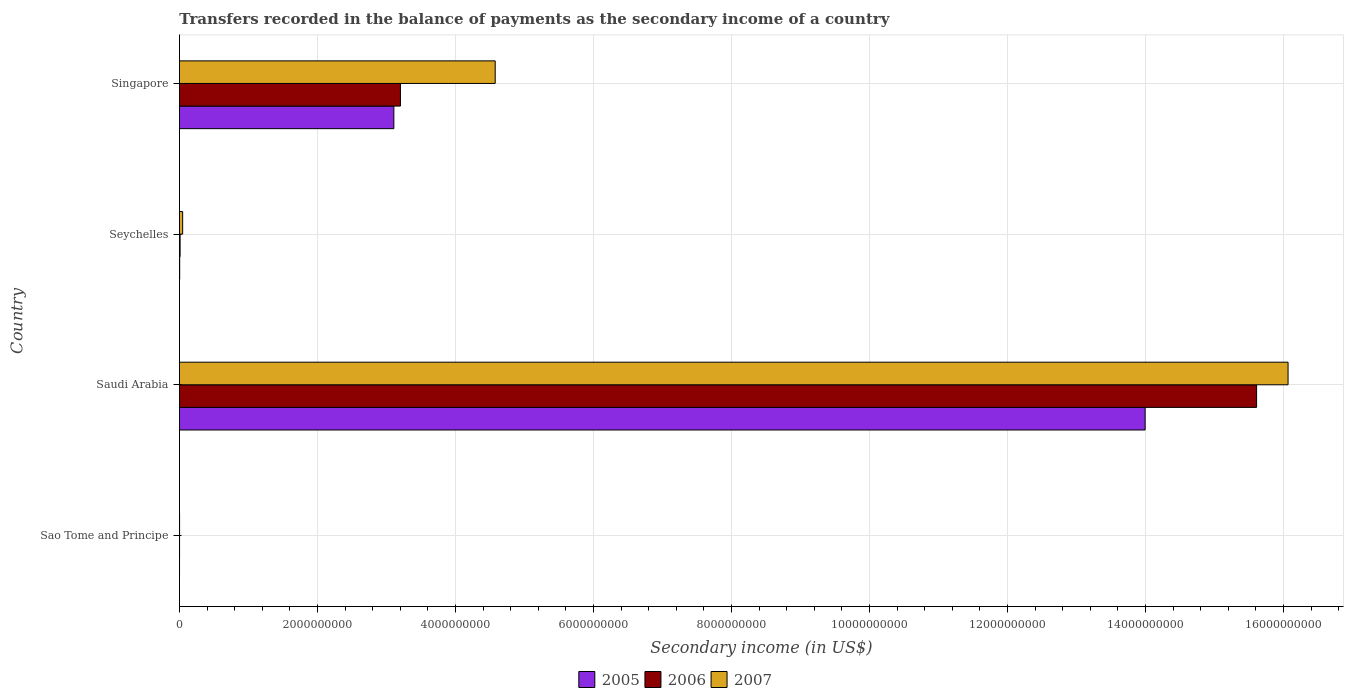Are the number of bars per tick equal to the number of legend labels?
Make the answer very short. Yes. Are the number of bars on each tick of the Y-axis equal?
Ensure brevity in your answer.  Yes. What is the label of the 2nd group of bars from the top?
Make the answer very short. Seychelles. In how many cases, is the number of bars for a given country not equal to the number of legend labels?
Provide a succinct answer. 0. What is the secondary income of in 2005 in Seychelles?
Make the answer very short. 3.99e+06. Across all countries, what is the maximum secondary income of in 2007?
Provide a succinct answer. 1.61e+1. Across all countries, what is the minimum secondary income of in 2005?
Offer a terse response. 1.46e+06. In which country was the secondary income of in 2005 maximum?
Offer a terse response. Saudi Arabia. In which country was the secondary income of in 2005 minimum?
Your response must be concise. Sao Tome and Principe. What is the total secondary income of in 2007 in the graph?
Your response must be concise. 2.07e+1. What is the difference between the secondary income of in 2005 in Sao Tome and Principe and that in Seychelles?
Give a very brief answer. -2.54e+06. What is the difference between the secondary income of in 2006 in Singapore and the secondary income of in 2007 in Sao Tome and Principe?
Offer a terse response. 3.20e+09. What is the average secondary income of in 2006 per country?
Ensure brevity in your answer.  4.71e+09. What is the difference between the secondary income of in 2007 and secondary income of in 2006 in Singapore?
Ensure brevity in your answer.  1.37e+09. In how many countries, is the secondary income of in 2006 greater than 8000000000 US$?
Make the answer very short. 1. What is the ratio of the secondary income of in 2006 in Sao Tome and Principe to that in Seychelles?
Your answer should be very brief. 0.23. Is the secondary income of in 2006 in Sao Tome and Principe less than that in Seychelles?
Offer a very short reply. Yes. What is the difference between the highest and the second highest secondary income of in 2005?
Your answer should be very brief. 1.09e+1. What is the difference between the highest and the lowest secondary income of in 2006?
Your answer should be compact. 1.56e+1. What does the 1st bar from the bottom in Singapore represents?
Your answer should be compact. 2005. Is it the case that in every country, the sum of the secondary income of in 2006 and secondary income of in 2005 is greater than the secondary income of in 2007?
Your answer should be compact. No. How many bars are there?
Make the answer very short. 12. Does the graph contain any zero values?
Offer a terse response. No. Where does the legend appear in the graph?
Ensure brevity in your answer.  Bottom center. How are the legend labels stacked?
Give a very brief answer. Horizontal. What is the title of the graph?
Provide a short and direct response. Transfers recorded in the balance of payments as the secondary income of a country. Does "1978" appear as one of the legend labels in the graph?
Offer a terse response. No. What is the label or title of the X-axis?
Give a very brief answer. Secondary income (in US$). What is the Secondary income (in US$) of 2005 in Sao Tome and Principe?
Your response must be concise. 1.46e+06. What is the Secondary income (in US$) in 2006 in Sao Tome and Principe?
Ensure brevity in your answer.  2.23e+06. What is the Secondary income (in US$) in 2007 in Sao Tome and Principe?
Your response must be concise. 2.27e+06. What is the Secondary income (in US$) in 2005 in Saudi Arabia?
Your answer should be very brief. 1.40e+1. What is the Secondary income (in US$) of 2006 in Saudi Arabia?
Make the answer very short. 1.56e+1. What is the Secondary income (in US$) in 2007 in Saudi Arabia?
Provide a succinct answer. 1.61e+1. What is the Secondary income (in US$) of 2005 in Seychelles?
Provide a succinct answer. 3.99e+06. What is the Secondary income (in US$) in 2006 in Seychelles?
Offer a terse response. 9.75e+06. What is the Secondary income (in US$) of 2007 in Seychelles?
Your response must be concise. 4.69e+07. What is the Secondary income (in US$) of 2005 in Singapore?
Ensure brevity in your answer.  3.11e+09. What is the Secondary income (in US$) in 2006 in Singapore?
Keep it short and to the point. 3.20e+09. What is the Secondary income (in US$) in 2007 in Singapore?
Give a very brief answer. 4.58e+09. Across all countries, what is the maximum Secondary income (in US$) of 2005?
Your answer should be compact. 1.40e+1. Across all countries, what is the maximum Secondary income (in US$) in 2006?
Your answer should be very brief. 1.56e+1. Across all countries, what is the maximum Secondary income (in US$) of 2007?
Provide a succinct answer. 1.61e+1. Across all countries, what is the minimum Secondary income (in US$) in 2005?
Offer a terse response. 1.46e+06. Across all countries, what is the minimum Secondary income (in US$) of 2006?
Your answer should be compact. 2.23e+06. Across all countries, what is the minimum Secondary income (in US$) of 2007?
Provide a short and direct response. 2.27e+06. What is the total Secondary income (in US$) in 2005 in the graph?
Ensure brevity in your answer.  1.71e+1. What is the total Secondary income (in US$) of 2006 in the graph?
Offer a very short reply. 1.88e+1. What is the total Secondary income (in US$) of 2007 in the graph?
Provide a succinct answer. 2.07e+1. What is the difference between the Secondary income (in US$) in 2005 in Sao Tome and Principe and that in Saudi Arabia?
Your answer should be compact. -1.40e+1. What is the difference between the Secondary income (in US$) in 2006 in Sao Tome and Principe and that in Saudi Arabia?
Make the answer very short. -1.56e+1. What is the difference between the Secondary income (in US$) of 2007 in Sao Tome and Principe and that in Saudi Arabia?
Keep it short and to the point. -1.61e+1. What is the difference between the Secondary income (in US$) of 2005 in Sao Tome and Principe and that in Seychelles?
Your response must be concise. -2.54e+06. What is the difference between the Secondary income (in US$) in 2006 in Sao Tome and Principe and that in Seychelles?
Give a very brief answer. -7.52e+06. What is the difference between the Secondary income (in US$) in 2007 in Sao Tome and Principe and that in Seychelles?
Give a very brief answer. -4.47e+07. What is the difference between the Secondary income (in US$) of 2005 in Sao Tome and Principe and that in Singapore?
Your answer should be compact. -3.11e+09. What is the difference between the Secondary income (in US$) of 2006 in Sao Tome and Principe and that in Singapore?
Ensure brevity in your answer.  -3.20e+09. What is the difference between the Secondary income (in US$) of 2007 in Sao Tome and Principe and that in Singapore?
Provide a short and direct response. -4.57e+09. What is the difference between the Secondary income (in US$) in 2005 in Saudi Arabia and that in Seychelles?
Offer a very short reply. 1.40e+1. What is the difference between the Secondary income (in US$) of 2006 in Saudi Arabia and that in Seychelles?
Keep it short and to the point. 1.56e+1. What is the difference between the Secondary income (in US$) in 2007 in Saudi Arabia and that in Seychelles?
Keep it short and to the point. 1.60e+1. What is the difference between the Secondary income (in US$) of 2005 in Saudi Arabia and that in Singapore?
Make the answer very short. 1.09e+1. What is the difference between the Secondary income (in US$) of 2006 in Saudi Arabia and that in Singapore?
Your answer should be very brief. 1.24e+1. What is the difference between the Secondary income (in US$) of 2007 in Saudi Arabia and that in Singapore?
Make the answer very short. 1.15e+1. What is the difference between the Secondary income (in US$) in 2005 in Seychelles and that in Singapore?
Give a very brief answer. -3.10e+09. What is the difference between the Secondary income (in US$) in 2006 in Seychelles and that in Singapore?
Your answer should be very brief. -3.19e+09. What is the difference between the Secondary income (in US$) in 2007 in Seychelles and that in Singapore?
Offer a terse response. -4.53e+09. What is the difference between the Secondary income (in US$) in 2005 in Sao Tome and Principe and the Secondary income (in US$) in 2006 in Saudi Arabia?
Make the answer very short. -1.56e+1. What is the difference between the Secondary income (in US$) of 2005 in Sao Tome and Principe and the Secondary income (in US$) of 2007 in Saudi Arabia?
Offer a very short reply. -1.61e+1. What is the difference between the Secondary income (in US$) in 2006 in Sao Tome and Principe and the Secondary income (in US$) in 2007 in Saudi Arabia?
Give a very brief answer. -1.61e+1. What is the difference between the Secondary income (in US$) in 2005 in Sao Tome and Principe and the Secondary income (in US$) in 2006 in Seychelles?
Give a very brief answer. -8.29e+06. What is the difference between the Secondary income (in US$) of 2005 in Sao Tome and Principe and the Secondary income (in US$) of 2007 in Seychelles?
Make the answer very short. -4.55e+07. What is the difference between the Secondary income (in US$) in 2006 in Sao Tome and Principe and the Secondary income (in US$) in 2007 in Seychelles?
Give a very brief answer. -4.47e+07. What is the difference between the Secondary income (in US$) of 2005 in Sao Tome and Principe and the Secondary income (in US$) of 2006 in Singapore?
Offer a terse response. -3.20e+09. What is the difference between the Secondary income (in US$) in 2005 in Sao Tome and Principe and the Secondary income (in US$) in 2007 in Singapore?
Your answer should be very brief. -4.58e+09. What is the difference between the Secondary income (in US$) in 2006 in Sao Tome and Principe and the Secondary income (in US$) in 2007 in Singapore?
Offer a terse response. -4.57e+09. What is the difference between the Secondary income (in US$) of 2005 in Saudi Arabia and the Secondary income (in US$) of 2006 in Seychelles?
Offer a terse response. 1.40e+1. What is the difference between the Secondary income (in US$) in 2005 in Saudi Arabia and the Secondary income (in US$) in 2007 in Seychelles?
Your response must be concise. 1.39e+1. What is the difference between the Secondary income (in US$) of 2006 in Saudi Arabia and the Secondary income (in US$) of 2007 in Seychelles?
Keep it short and to the point. 1.56e+1. What is the difference between the Secondary income (in US$) of 2005 in Saudi Arabia and the Secondary income (in US$) of 2006 in Singapore?
Your answer should be very brief. 1.08e+1. What is the difference between the Secondary income (in US$) in 2005 in Saudi Arabia and the Secondary income (in US$) in 2007 in Singapore?
Provide a succinct answer. 9.42e+09. What is the difference between the Secondary income (in US$) of 2006 in Saudi Arabia and the Secondary income (in US$) of 2007 in Singapore?
Offer a terse response. 1.10e+1. What is the difference between the Secondary income (in US$) of 2005 in Seychelles and the Secondary income (in US$) of 2006 in Singapore?
Provide a succinct answer. -3.20e+09. What is the difference between the Secondary income (in US$) of 2005 in Seychelles and the Secondary income (in US$) of 2007 in Singapore?
Give a very brief answer. -4.57e+09. What is the difference between the Secondary income (in US$) in 2006 in Seychelles and the Secondary income (in US$) in 2007 in Singapore?
Offer a terse response. -4.57e+09. What is the average Secondary income (in US$) of 2005 per country?
Provide a short and direct response. 4.28e+09. What is the average Secondary income (in US$) in 2006 per country?
Your response must be concise. 4.71e+09. What is the average Secondary income (in US$) of 2007 per country?
Provide a succinct answer. 5.17e+09. What is the difference between the Secondary income (in US$) in 2005 and Secondary income (in US$) in 2006 in Sao Tome and Principe?
Make the answer very short. -7.71e+05. What is the difference between the Secondary income (in US$) of 2005 and Secondary income (in US$) of 2007 in Sao Tome and Principe?
Your answer should be very brief. -8.14e+05. What is the difference between the Secondary income (in US$) in 2006 and Secondary income (in US$) in 2007 in Sao Tome and Principe?
Make the answer very short. -4.38e+04. What is the difference between the Secondary income (in US$) in 2005 and Secondary income (in US$) in 2006 in Saudi Arabia?
Offer a very short reply. -1.62e+09. What is the difference between the Secondary income (in US$) in 2005 and Secondary income (in US$) in 2007 in Saudi Arabia?
Your answer should be compact. -2.07e+09. What is the difference between the Secondary income (in US$) of 2006 and Secondary income (in US$) of 2007 in Saudi Arabia?
Provide a succinct answer. -4.56e+08. What is the difference between the Secondary income (in US$) in 2005 and Secondary income (in US$) in 2006 in Seychelles?
Provide a short and direct response. -5.75e+06. What is the difference between the Secondary income (in US$) of 2005 and Secondary income (in US$) of 2007 in Seychelles?
Keep it short and to the point. -4.29e+07. What is the difference between the Secondary income (in US$) of 2006 and Secondary income (in US$) of 2007 in Seychelles?
Keep it short and to the point. -3.72e+07. What is the difference between the Secondary income (in US$) of 2005 and Secondary income (in US$) of 2006 in Singapore?
Provide a succinct answer. -9.54e+07. What is the difference between the Secondary income (in US$) in 2005 and Secondary income (in US$) in 2007 in Singapore?
Give a very brief answer. -1.47e+09. What is the difference between the Secondary income (in US$) of 2006 and Secondary income (in US$) of 2007 in Singapore?
Your answer should be compact. -1.37e+09. What is the ratio of the Secondary income (in US$) in 2005 in Sao Tome and Principe to that in Saudi Arabia?
Keep it short and to the point. 0. What is the ratio of the Secondary income (in US$) of 2006 in Sao Tome and Principe to that in Saudi Arabia?
Ensure brevity in your answer.  0. What is the ratio of the Secondary income (in US$) of 2005 in Sao Tome and Principe to that in Seychelles?
Offer a terse response. 0.36. What is the ratio of the Secondary income (in US$) of 2006 in Sao Tome and Principe to that in Seychelles?
Provide a succinct answer. 0.23. What is the ratio of the Secondary income (in US$) of 2007 in Sao Tome and Principe to that in Seychelles?
Keep it short and to the point. 0.05. What is the ratio of the Secondary income (in US$) of 2006 in Sao Tome and Principe to that in Singapore?
Keep it short and to the point. 0. What is the ratio of the Secondary income (in US$) in 2007 in Sao Tome and Principe to that in Singapore?
Offer a very short reply. 0. What is the ratio of the Secondary income (in US$) of 2005 in Saudi Arabia to that in Seychelles?
Give a very brief answer. 3503.45. What is the ratio of the Secondary income (in US$) in 2006 in Saudi Arabia to that in Seychelles?
Keep it short and to the point. 1601.86. What is the ratio of the Secondary income (in US$) in 2007 in Saudi Arabia to that in Seychelles?
Give a very brief answer. 342.26. What is the ratio of the Secondary income (in US$) in 2005 in Saudi Arabia to that in Singapore?
Provide a short and direct response. 4.5. What is the ratio of the Secondary income (in US$) of 2006 in Saudi Arabia to that in Singapore?
Make the answer very short. 4.87. What is the ratio of the Secondary income (in US$) in 2007 in Saudi Arabia to that in Singapore?
Make the answer very short. 3.51. What is the ratio of the Secondary income (in US$) in 2005 in Seychelles to that in Singapore?
Offer a terse response. 0. What is the ratio of the Secondary income (in US$) of 2006 in Seychelles to that in Singapore?
Ensure brevity in your answer.  0. What is the ratio of the Secondary income (in US$) of 2007 in Seychelles to that in Singapore?
Give a very brief answer. 0.01. What is the difference between the highest and the second highest Secondary income (in US$) of 2005?
Ensure brevity in your answer.  1.09e+1. What is the difference between the highest and the second highest Secondary income (in US$) in 2006?
Ensure brevity in your answer.  1.24e+1. What is the difference between the highest and the second highest Secondary income (in US$) of 2007?
Your response must be concise. 1.15e+1. What is the difference between the highest and the lowest Secondary income (in US$) in 2005?
Ensure brevity in your answer.  1.40e+1. What is the difference between the highest and the lowest Secondary income (in US$) in 2006?
Provide a succinct answer. 1.56e+1. What is the difference between the highest and the lowest Secondary income (in US$) of 2007?
Provide a short and direct response. 1.61e+1. 